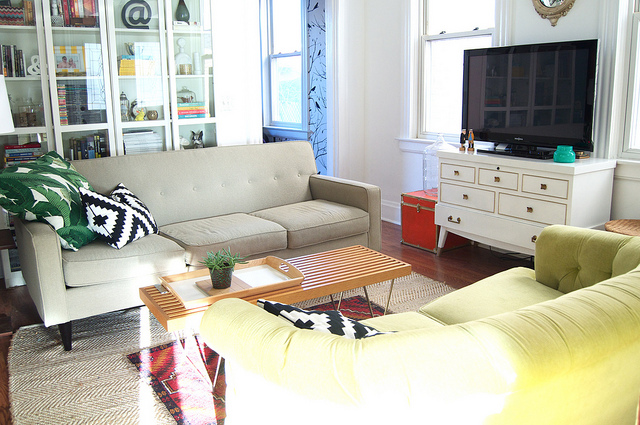What are some design elements in this room that make it feel cozy? Several design elements contribute to the cozy atmosphere of the room, including the plush green armchair that invites relaxation, the soft throw pillows, and the warm ambient lighting. The woven rug underfoot adds texture and warmth, while the book-filled cabinet and personal decorative items lend a lived-in, homely feel to the space. 